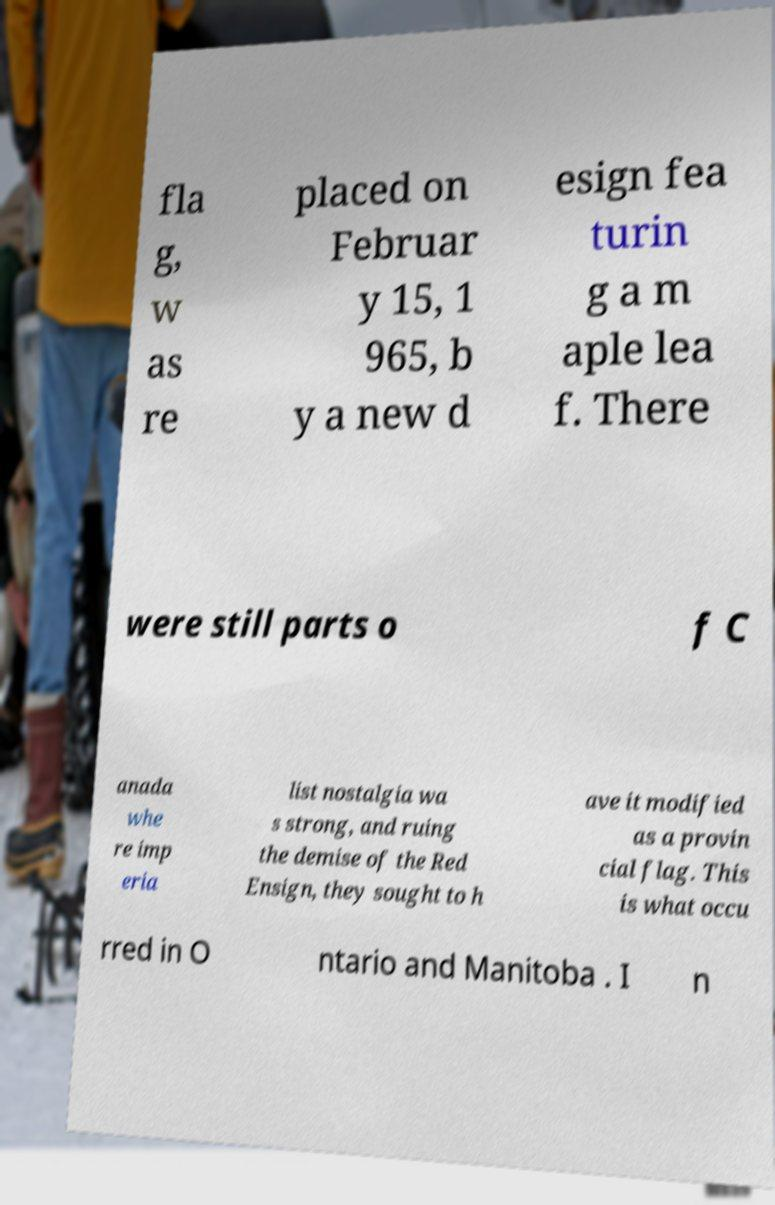Please identify and transcribe the text found in this image. fla g, w as re placed on Februar y 15, 1 965, b y a new d esign fea turin g a m aple lea f. There were still parts o f C anada whe re imp eria list nostalgia wa s strong, and ruing the demise of the Red Ensign, they sought to h ave it modified as a provin cial flag. This is what occu rred in O ntario and Manitoba . I n 